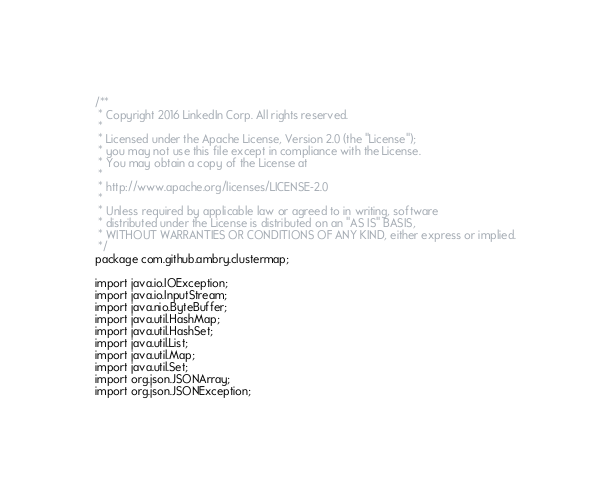<code> <loc_0><loc_0><loc_500><loc_500><_Java_>/**
 * Copyright 2016 LinkedIn Corp. All rights reserved.
 *
 * Licensed under the Apache License, Version 2.0 (the "License");
 * you may not use this file except in compliance with the License.
 * You may obtain a copy of the License at
 *
 * http://www.apache.org/licenses/LICENSE-2.0
 *
 * Unless required by applicable law or agreed to in writing, software
 * distributed under the License is distributed on an "AS IS" BASIS,
 * WITHOUT WARRANTIES OR CONDITIONS OF ANY KIND, either express or implied.
 */
package com.github.ambry.clustermap;

import java.io.IOException;
import java.io.InputStream;
import java.nio.ByteBuffer;
import java.util.HashMap;
import java.util.HashSet;
import java.util.List;
import java.util.Map;
import java.util.Set;
import org.json.JSONArray;
import org.json.JSONException;</code> 